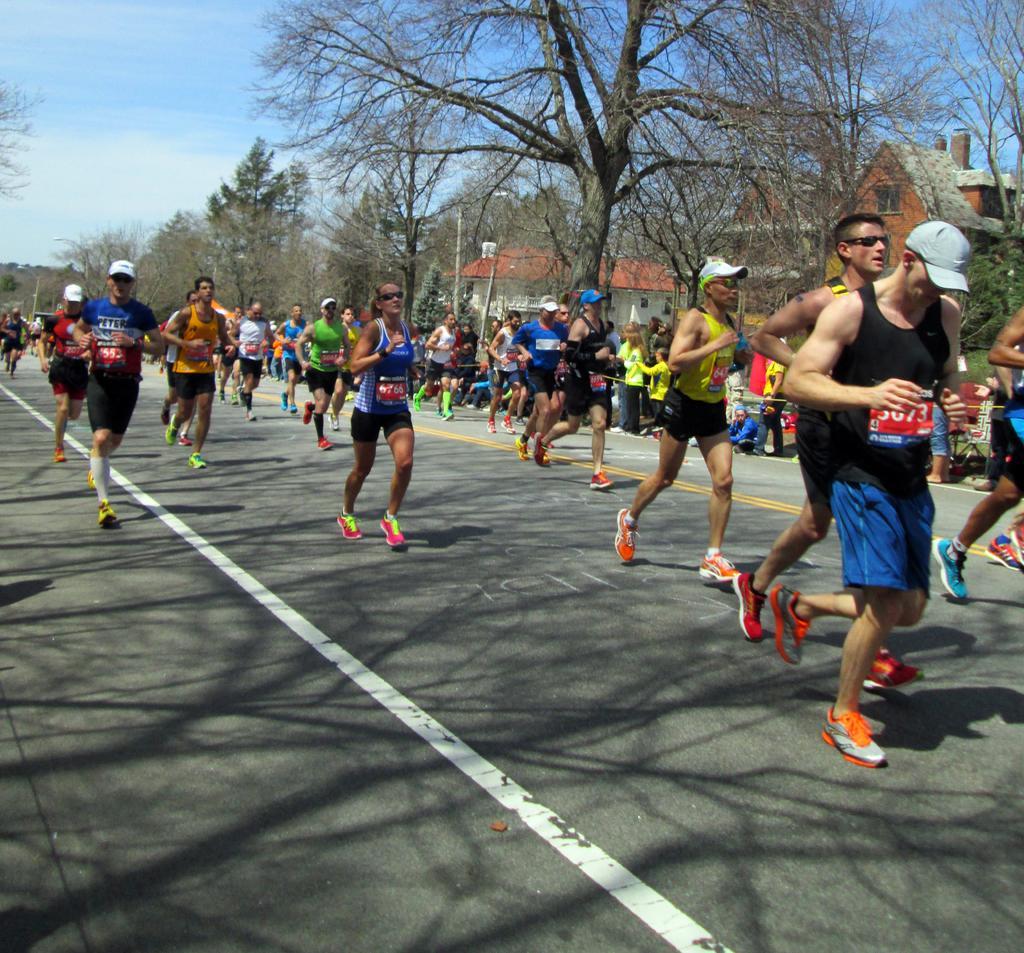How would you summarize this image in a sentence or two? In the center of the image we can see people running on the road. In the background there are trees, buildings and sky. 